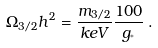<formula> <loc_0><loc_0><loc_500><loc_500>\Omega _ { 3 / 2 } h ^ { 2 } = \frac { m _ { 3 / 2 } } { k e V } \frac { 1 0 0 } { g _ { ^ { * } } } \, .</formula> 